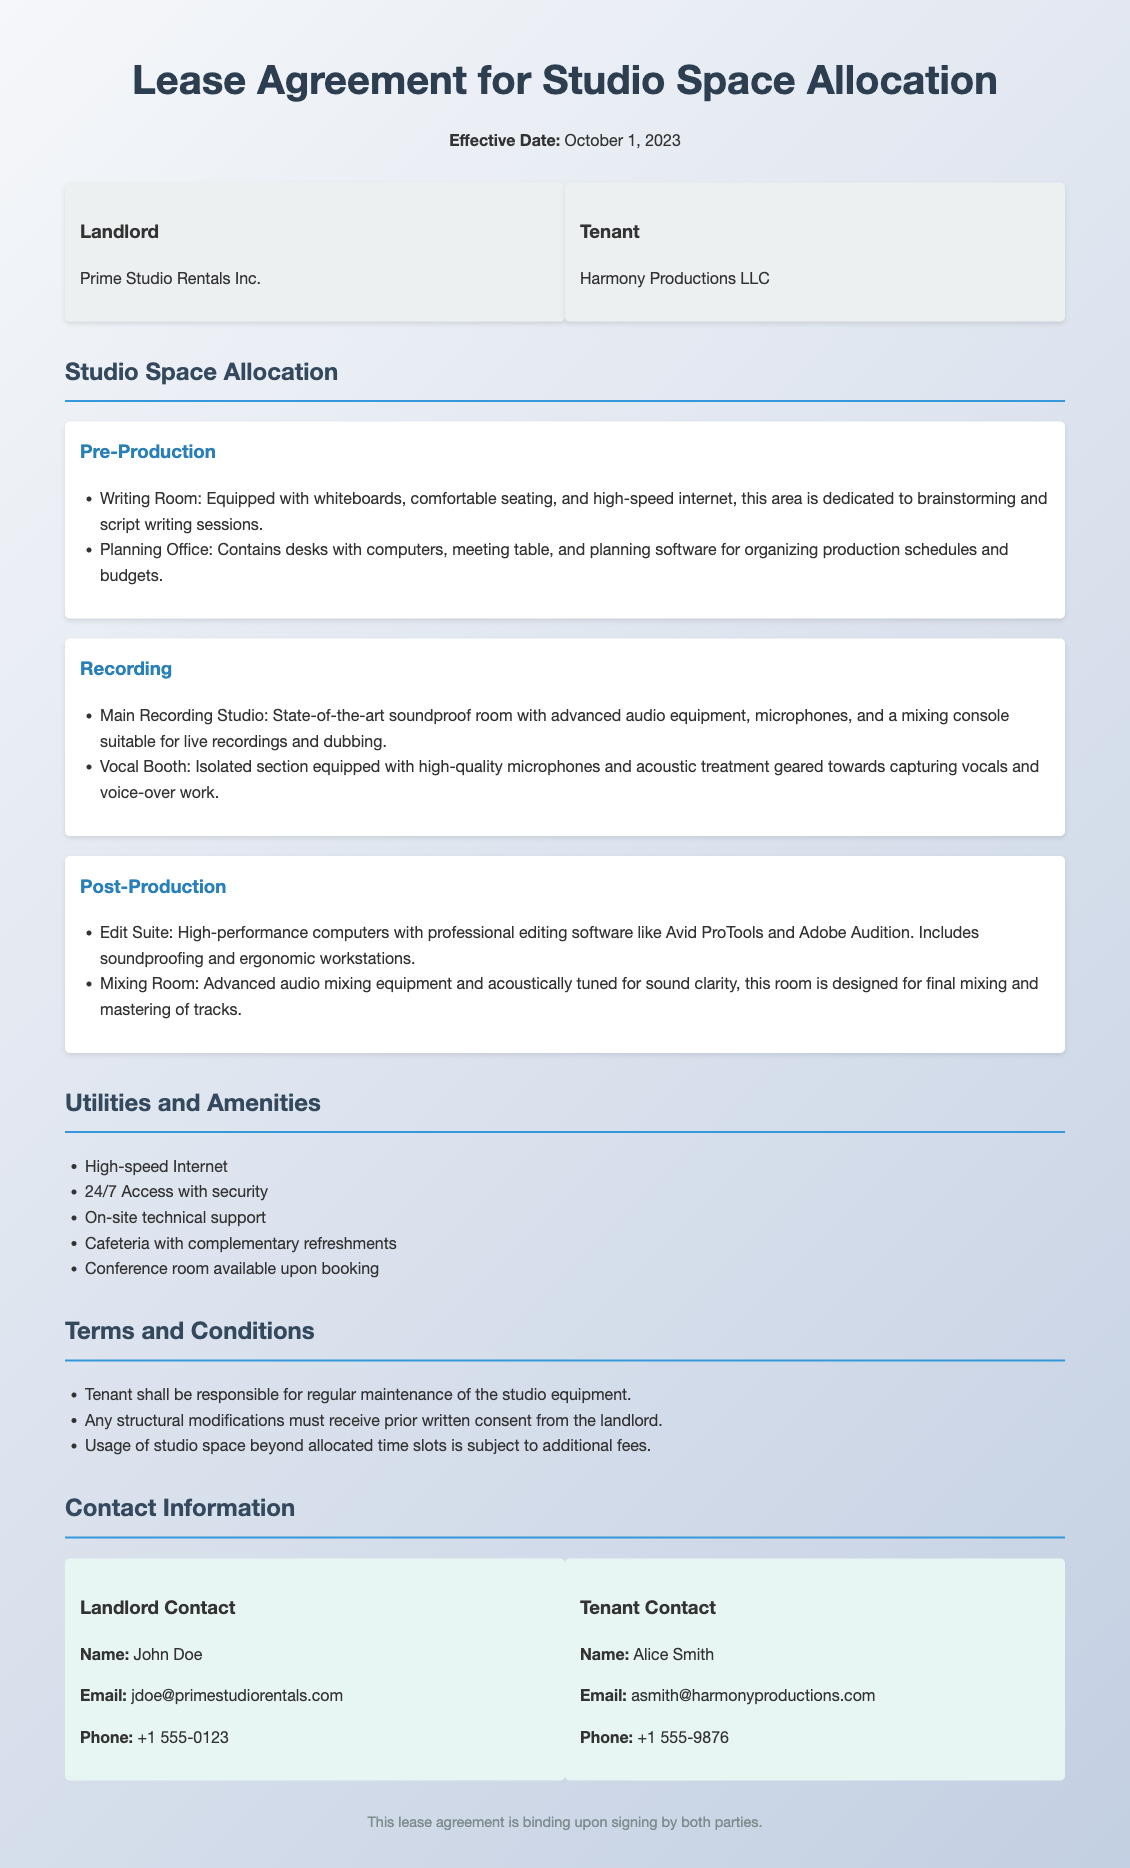What is the effective date of the lease agreement? The effective date is clearly stated at the top of the document.
Answer: October 1, 2023 Who is the landlord? The document specifies the name of the landlord in the parties section.
Answer: Prime Studio Rentals Inc What amenities are included in the lease? The amenities listed are often found in the utilities and amenities section.
Answer: High-speed Internet, 24/7 Access with security, On-site technical support, Cafeteria with complementary refreshments, Conference room available upon booking What area is designated for brainstorming and script writing sessions? The document details specific areas for various production phases.
Answer: Writing Room What is the responsibility of the tenant regarding studio equipment? The terms and conditions section includes obligations for the tenant.
Answer: Regular maintenance Which room is designed for final mixing and mastering of tracks? The post-production section outlines specific rooms for respective uses.
Answer: Mixing Room How many contact numbers are provided in the document? The contact information section contains contact numbers for both the landlord and tenant.
Answer: Two Who is the tenant's contact person? The identity of the tenant's contact is specified in the contact information section.
Answer: Alice Smith 